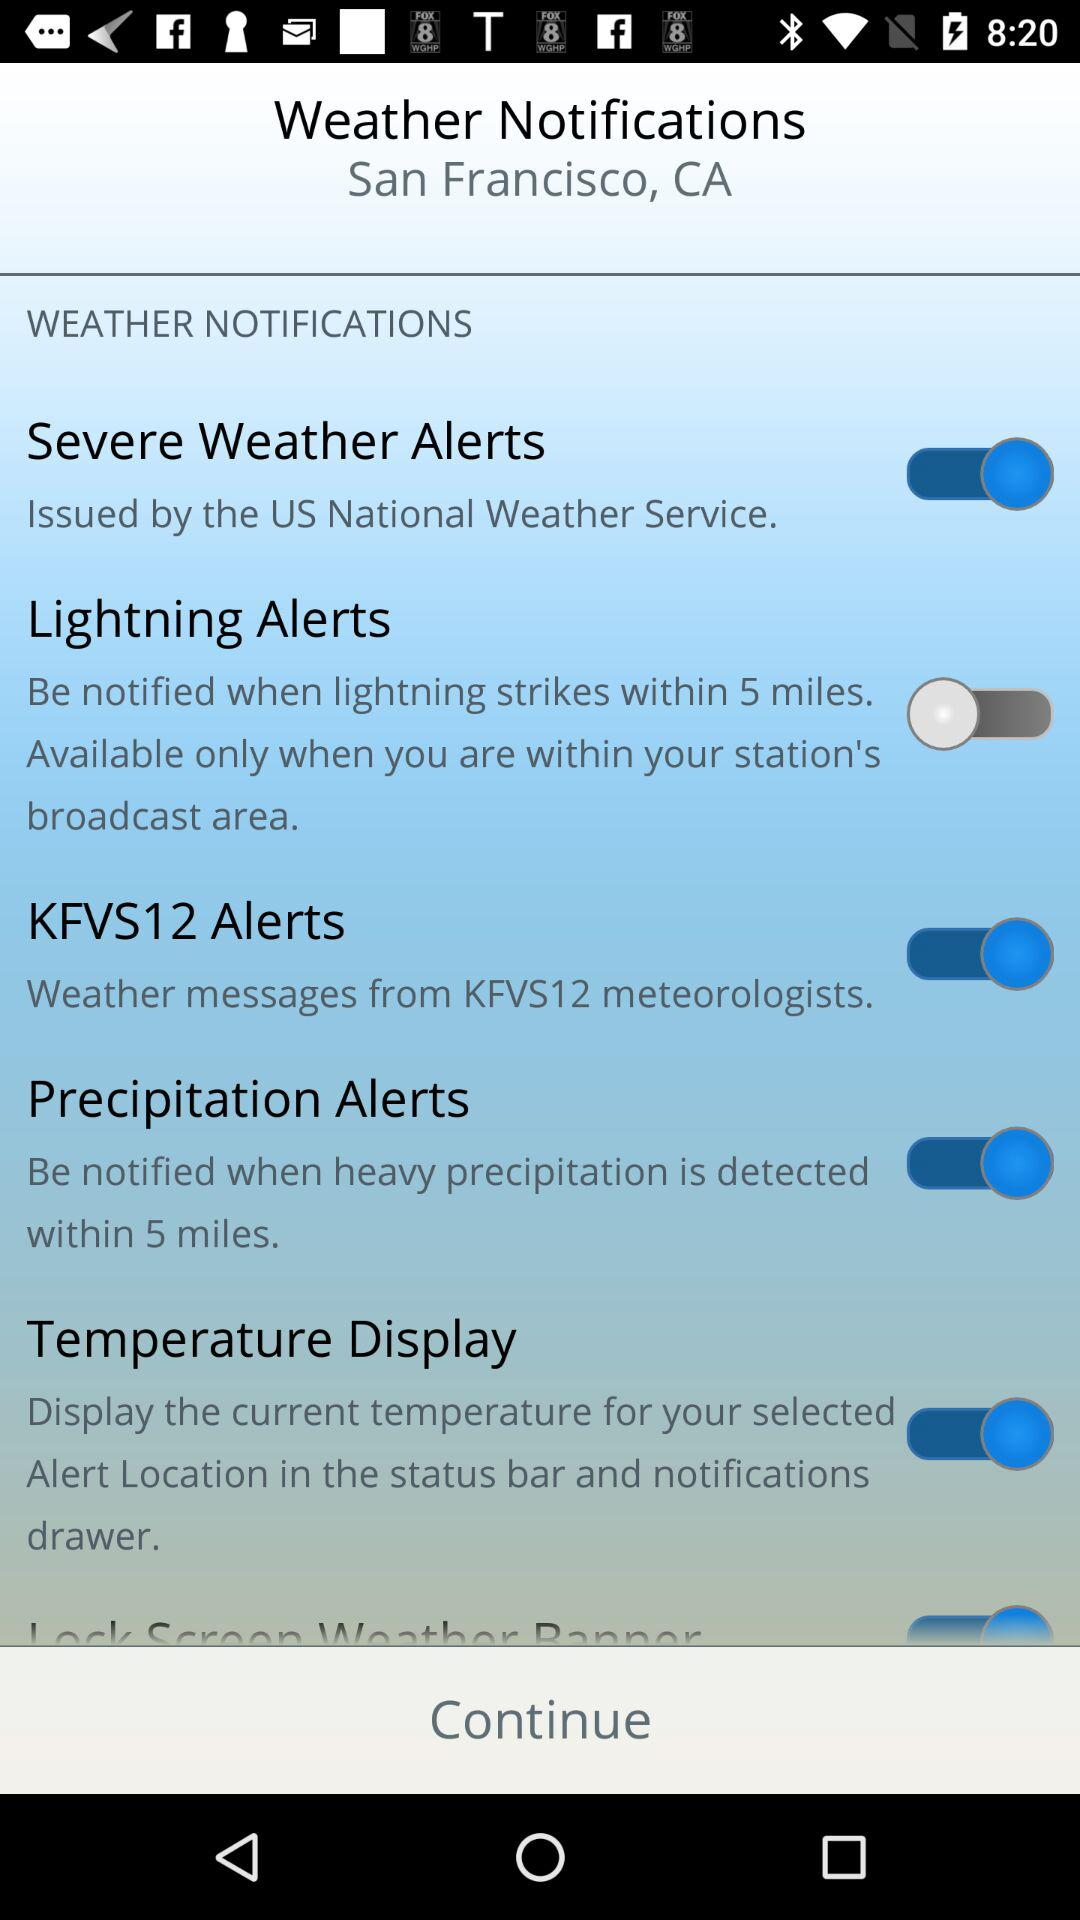What is the current status of the "Severe Weather Alerts"? The current status is "on". 